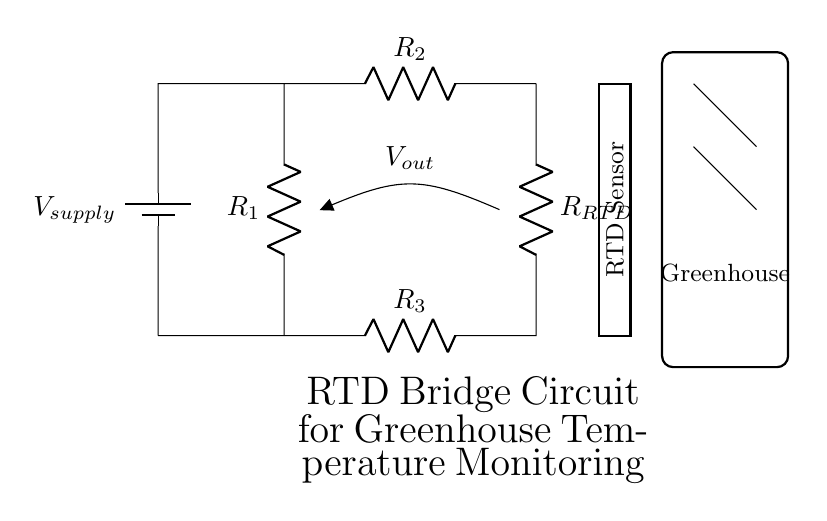What type of circuit is displayed? The circuit shown is a bridge circuit, characterized by its structure that uses multiple resistors arranged in a closed loop for measuring resistance changes.
Answer: Bridge What component is labeled as R3? R3 is one of the resistors in the bridge circuit, which connects the bottom left junction to the bottom right junction, influencing the overall balance of the bridge.
Answer: R3 How many resistors are in the circuit? The circuit contains four resistors: R1, R2, R3, and the resistance temperature detector (RTD) component, which is treated as a resistor in this configuration.
Answer: Four What does Vout measure in this circuit? Vout measures the voltage difference between the two midpoints of the bridge, which indicates the balance between the resistors and reveals temperature changes detected by the RTD.
Answer: Voltage difference What is the role of the RTD in this circuit? The RTD serves as the temperature sensing element that changes its resistance based on the temperature, impacting the voltage output of the bridge circuit.
Answer: Temperature sensor What is the purpose of the battery in this circuit? The battery provides the necessary supply voltage to the circuit, enabling current to flow through the resistors and allowing for the measurement of the output voltage based on the bridge configuration.
Answer: Supply voltage What does the rectangle labeled "Greenhouse" represent? The rectangle labeled "Greenhouse" visually indicates the environment where the RTD sensor is located, emphasizing the practical application of the circuit in monitoring greenhouse temperatures.
Answer: Environment 